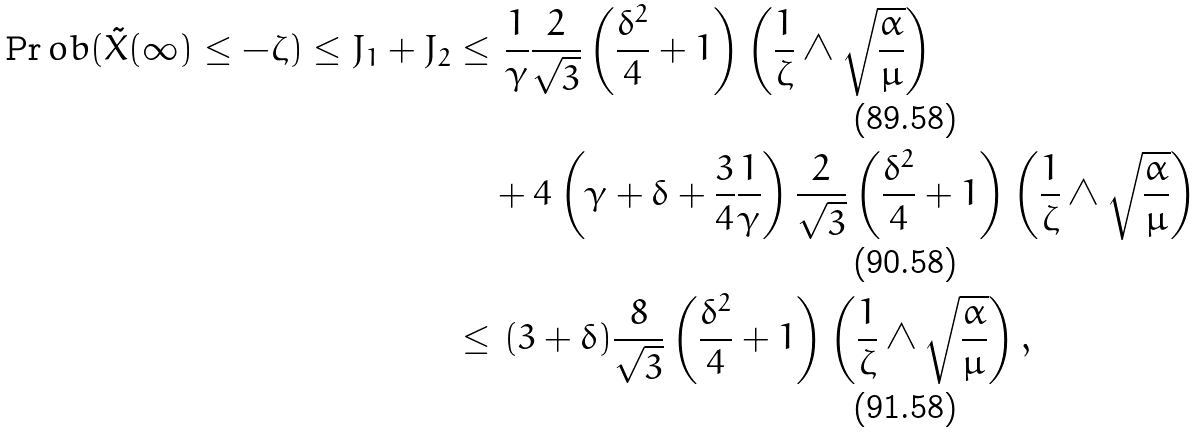<formula> <loc_0><loc_0><loc_500><loc_500>\Pr o b ( \tilde { X } ( \infty ) \leq - \zeta ) \leq J _ { 1 } + J _ { 2 } \leq & \ \frac { 1 } { \gamma } \frac { 2 } { \sqrt { 3 } } \left ( \frac { \delta ^ { 2 } } { 4 } + 1 \right ) \left ( \frac { 1 } { \zeta } \wedge \sqrt { \frac { \alpha } { \mu } } \right ) \\ & + 4 \left ( \gamma + \delta + \frac { 3 } { 4 } \frac { 1 } { \gamma } \right ) \frac { 2 } { \sqrt { 3 } } \left ( \frac { \delta ^ { 2 } } { 4 } + 1 \right ) \left ( \frac { 1 } { \zeta } \wedge \sqrt { \frac { \alpha } { \mu } } \right ) \\ \leq & \ ( 3 + \delta ) \frac { 8 } { \sqrt { 3 } } \left ( \frac { \delta ^ { 2 } } { 4 } + 1 \right ) \left ( \frac { 1 } { \zeta } \wedge \sqrt { \frac { \alpha } { \mu } } \right ) ,</formula> 